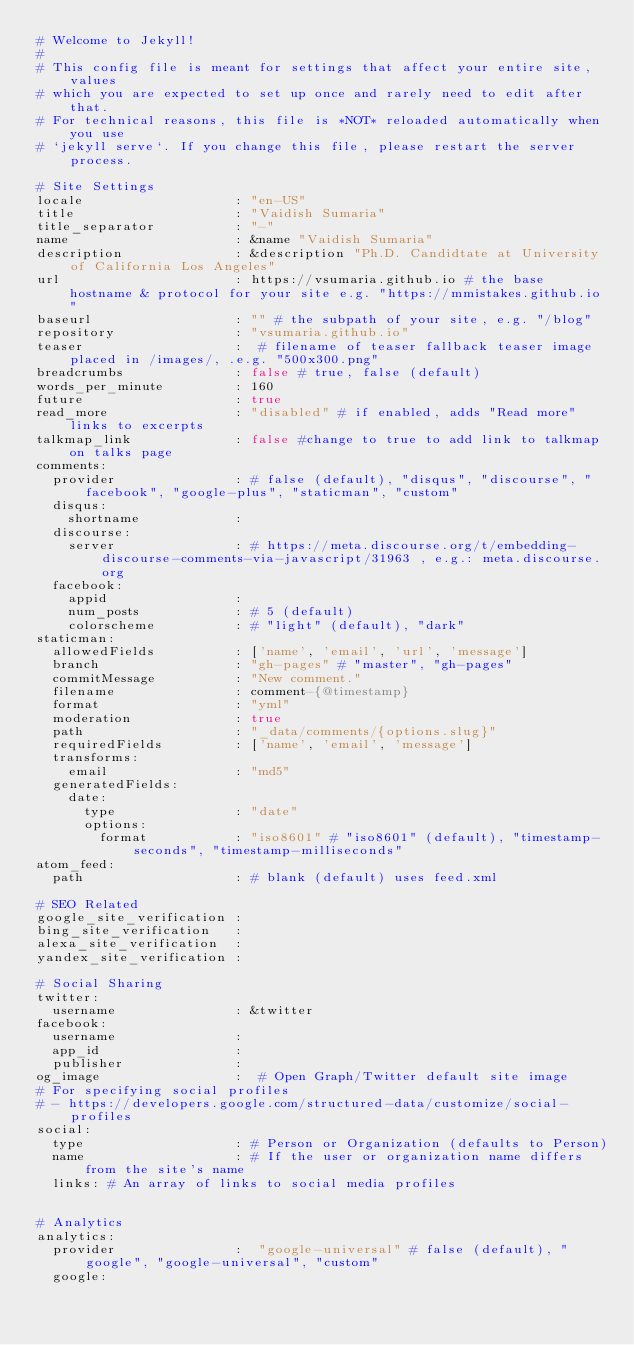<code> <loc_0><loc_0><loc_500><loc_500><_YAML_># Welcome to Jekyll!
#
# This config file is meant for settings that affect your entire site, values
# which you are expected to set up once and rarely need to edit after that.
# For technical reasons, this file is *NOT* reloaded automatically when you use
# `jekyll serve`. If you change this file, please restart the server process.

# Site Settings
locale                   : "en-US"
title                    : "Vaidish Sumaria"
title_separator          : "-"
name                     : &name "Vaidish Sumaria"
description              : &description "Ph.D. Candidtate at University of California Los Angeles"
url                      : https://vsumaria.github.io # the base hostname & protocol for your site e.g. "https://mmistakes.github.io"
baseurl                  : "" # the subpath of your site, e.g. "/blog"
repository               : "vsumaria.github.io"
teaser                   :  # filename of teaser fallback teaser image placed in /images/, .e.g. "500x300.png"
breadcrumbs              : false # true, false (default)
words_per_minute         : 160
future                   : true
read_more                : "disabled" # if enabled, adds "Read more" links to excerpts
talkmap_link             : false #change to true to add link to talkmap on talks page
comments:
  provider               : # false (default), "disqus", "discourse", "facebook", "google-plus", "staticman", "custom"
  disqus:
    shortname            :
  discourse:
    server               : # https://meta.discourse.org/t/embedding-discourse-comments-via-javascript/31963 , e.g.: meta.discourse.org
  facebook:
    appid                :
    num_posts            : # 5 (default)
    colorscheme          : # "light" (default), "dark"
staticman:
  allowedFields          : ['name', 'email', 'url', 'message']
  branch                 : "gh-pages" # "master", "gh-pages"
  commitMessage          : "New comment."
  filename               : comment-{@timestamp}
  format                 : "yml"
  moderation             : true
  path                   : "_data/comments/{options.slug}"
  requiredFields         : ['name', 'email', 'message']
  transforms:
    email                : "md5"
  generatedFields:
    date:
      type               : "date"
      options:
        format           : "iso8601" # "iso8601" (default), "timestamp-seconds", "timestamp-milliseconds"
atom_feed:
  path                   : # blank (default) uses feed.xml

# SEO Related
google_site_verification :
bing_site_verification   :
alexa_site_verification  :
yandex_site_verification :

# Social Sharing
twitter:
  username               : &twitter
facebook:
  username               :
  app_id                 :
  publisher              :
og_image                 :  # Open Graph/Twitter default site image
# For specifying social profiles
# - https://developers.google.com/structured-data/customize/social-profiles
social:
  type                   : # Person or Organization (defaults to Person)
  name                   : # If the user or organization name differs from the site's name
  links: # An array of links to social media profiles


# Analytics
analytics:
  provider               :  "google-universal" # false (default), "google", "google-universal", "custom"
  google:</code> 